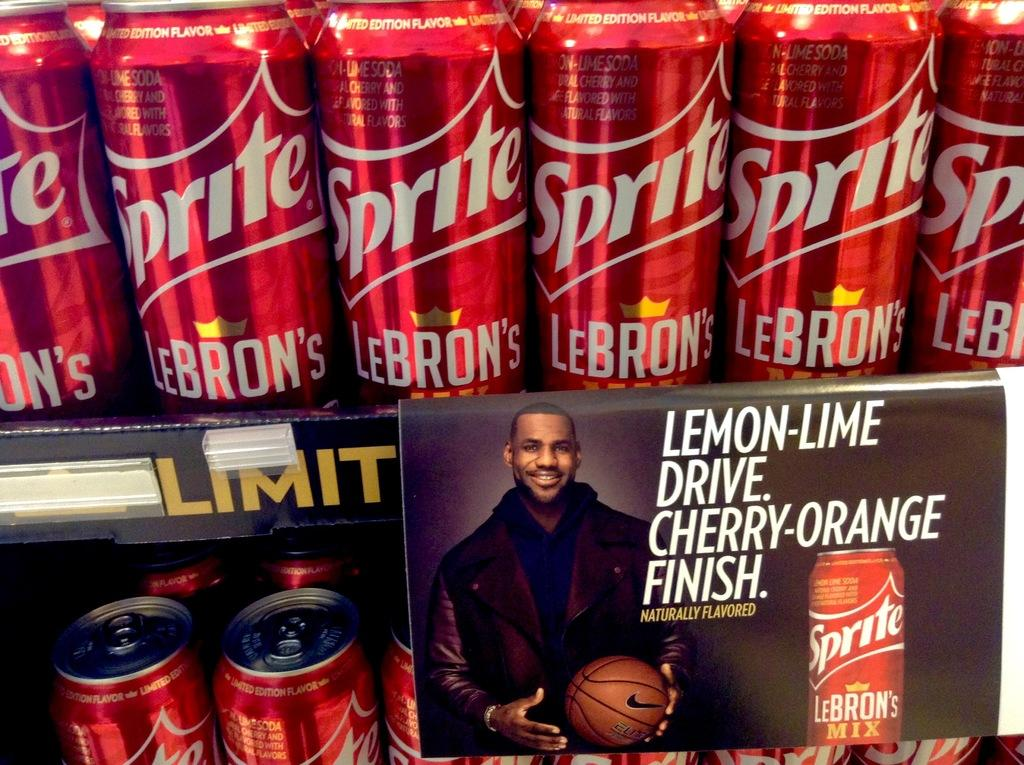<image>
Render a clear and concise summary of the photo. Red cans of Sprite has a picture of LeBron on the shelf. 